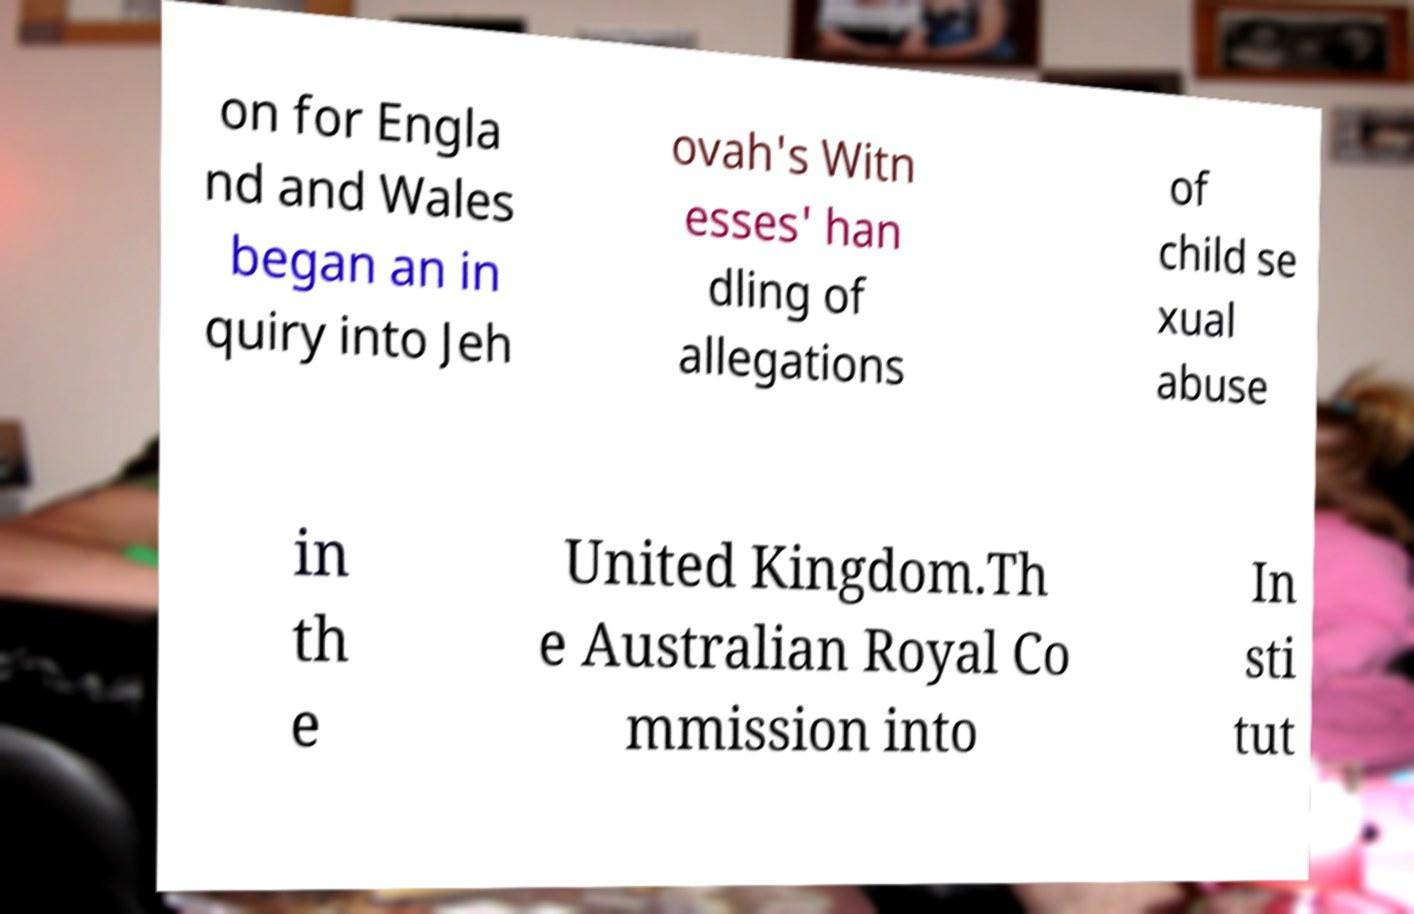Please identify and transcribe the text found in this image. on for Engla nd and Wales began an in quiry into Jeh ovah's Witn esses' han dling of allegations of child se xual abuse in th e United Kingdom.Th e Australian Royal Co mmission into In sti tut 